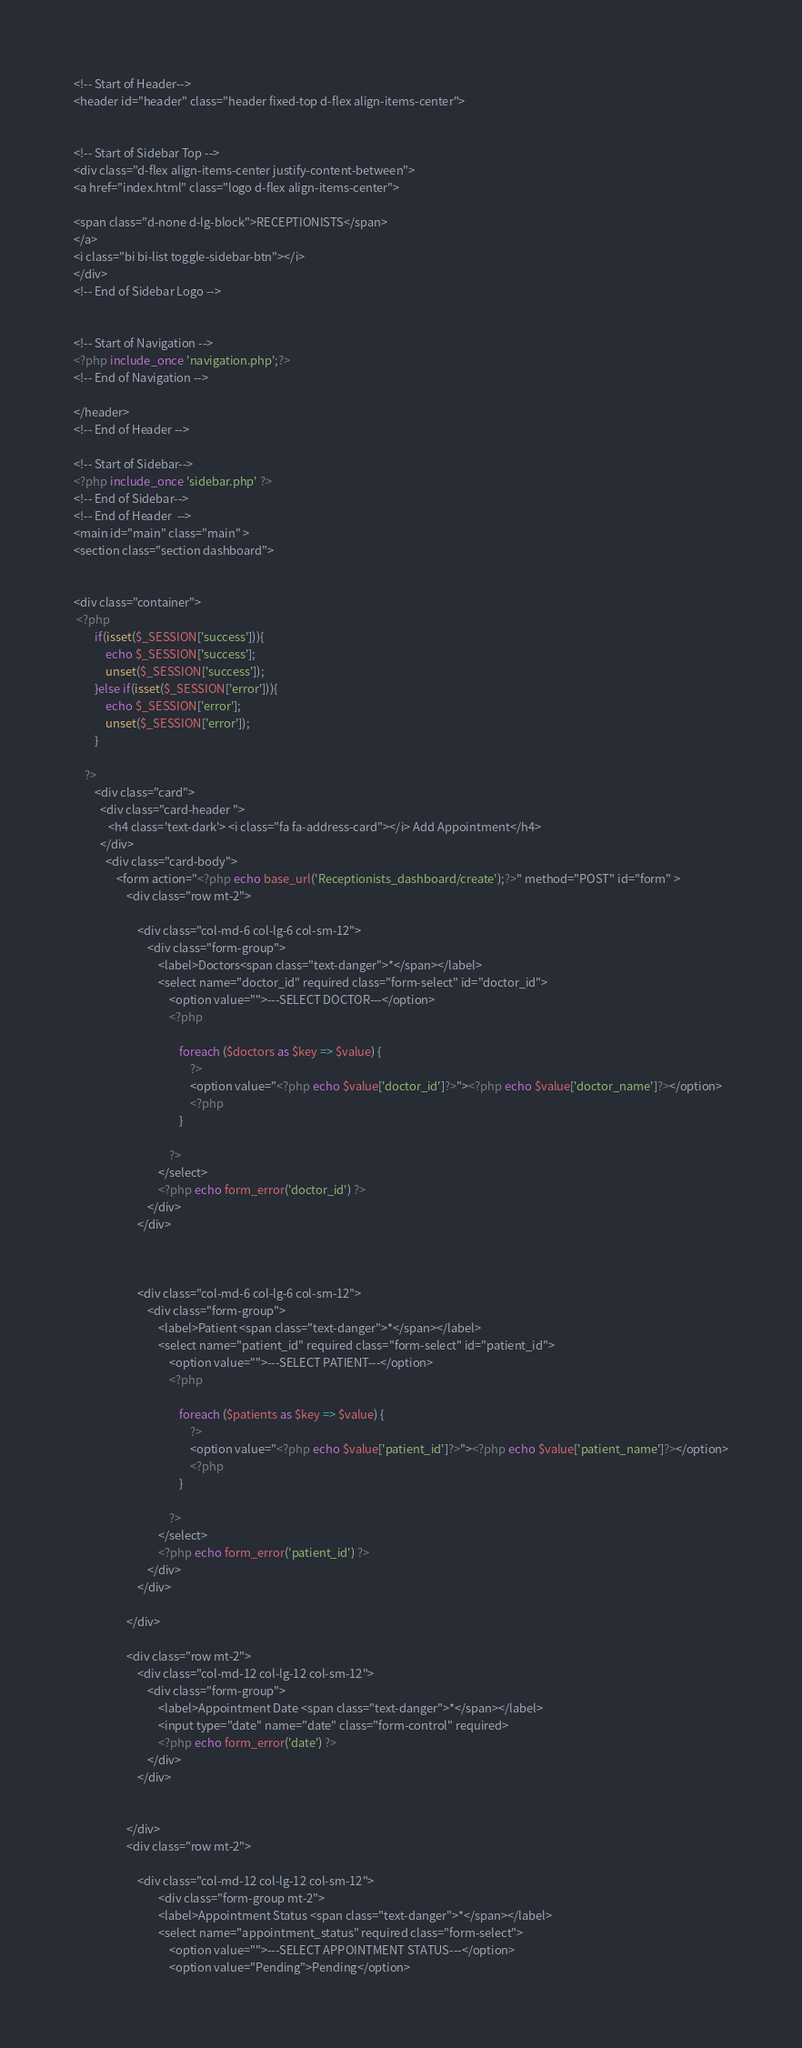<code> <loc_0><loc_0><loc_500><loc_500><_PHP_><!-- Start of Header-->
<header id="header" class="header fixed-top d-flex align-items-center">


<!-- Start of Sidebar Top -->
<div class="d-flex align-items-center justify-content-between">
<a href="index.html" class="logo d-flex align-items-center">

<span class="d-none d-lg-block">RECEPTIONISTS</span>
</a>
<i class="bi bi-list toggle-sidebar-btn"></i>
</div>
<!-- End of Sidebar Logo -->


<!-- Start of Navigation -->
<?php include_once 'navigation.php';?>
<!-- End of Navigation -->

</header>
<!-- End of Header -->

<!-- Start of Sidebar-->
<?php include_once 'sidebar.php' ?>
<!-- End of Sidebar-->
<!-- End of Header  -->
<main id="main" class="main"	>  
<section class="section dashboard">


<div class="container">
 <?php  
        if(isset($_SESSION['success'])){
            echo $_SESSION['success'];
            unset($_SESSION['success']);
        }else if(isset($_SESSION['error'])){
            echo $_SESSION['error'];
            unset($_SESSION['error']);
        }
        
    ?>
        <div class="card"> 
          <div class="card-header ">
             <h4 class='text-dark'> <i class="fa fa-address-card"></i> Add Appointment</h4>
          </div>
            <div class="card-body">
                <form action="<?php echo base_url('Receptionists_dashboard/create');?>" method="POST" id="form" >
                    <div class="row mt-2">

                        <div class="col-md-6 col-lg-6 col-sm-12">
                            <div class="form-group">
                                <label>Doctors<span class="text-danger">*</span></label>
                                <select name="doctor_id" required class="form-select" id="doctor_id">
                                    <option value="">---SELECT DOCTOR---</option>
                                    <?php 

                                        foreach ($doctors as $key => $value) {
                                            ?>
                                            <option value="<?php echo $value['doctor_id']?>"><?php echo $value['doctor_name']?></option>
                                            <?php
                                        }

                                    ?>
                                </select>
                                <?php echo form_error('doctor_id') ?>
                            </div>
                        </div>

                    

                        <div class="col-md-6 col-lg-6 col-sm-12">
                            <div class="form-group">
                                <label>Patient <span class="text-danger">*</span></label>
                                <select name="patient_id" required class="form-select" id="patient_id">
                                    <option value="">---SELECT PATIENT---</option>
                                    <?php 

                                        foreach ($patients as $key => $value) {
                                            ?>
                                            <option value="<?php echo $value['patient_id']?>"><?php echo $value['patient_name']?></option>
                                            <?php
                                        }

                                    ?>
                                </select>
                                <?php echo form_error('patient_id') ?>
                            </div>
                        </div>

                    </div>

                    <div class="row mt-2">
                        <div class="col-md-12 col-lg-12 col-sm-12">
                            <div class="form-group">
                                <label>Appointment Date <span class="text-danger">*</span></label>
                                <input type="date" name="date" class="form-control" required>
                                <?php echo form_error('date') ?>
                            </div>
                        </div>

                    
                    </div>
                    <div class="row mt-2">
                    
                        <div class="col-md-12 col-lg-12 col-sm-12">
                                <div class="form-group mt-2">
                                <label>Appointment Status <span class="text-danger">*</span></label>
                                <select name="appointment_status" required class="form-select">
                                    <option value="">---SELECT APPOINTMENT STATUS---</option>
                                    <option value="Pending">Pending</option></code> 